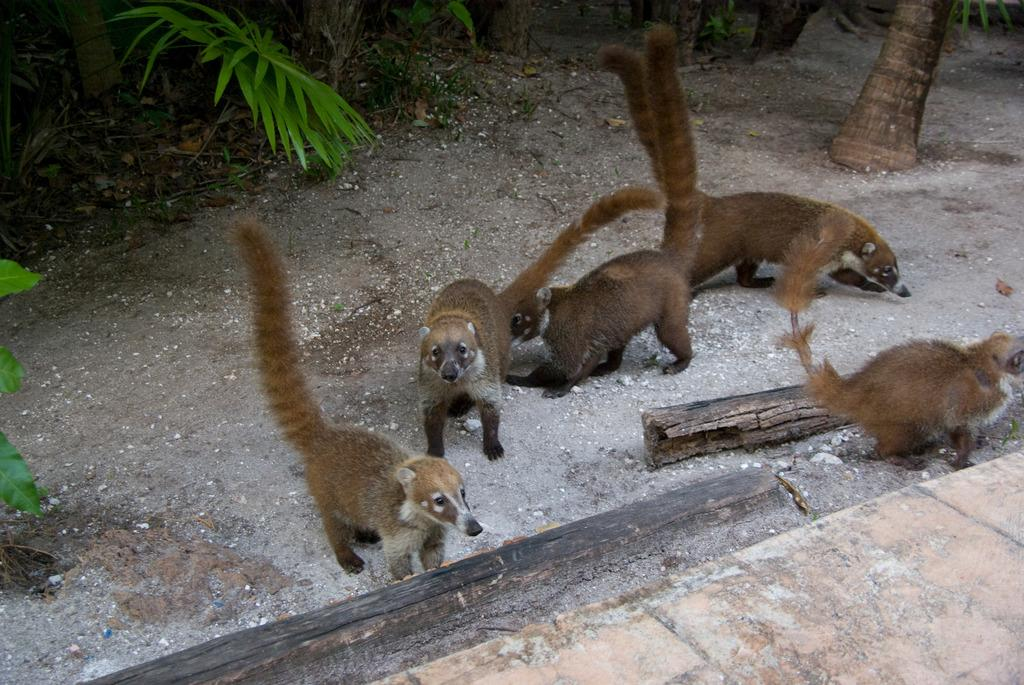How many animals are present in the image? There are five animals in the image. What is the setting of the image? The image appears to be taken in a forest. What can be seen at the bottom of the image? There is ground visible at the bottom of the image. What type of vegetation is visible in the background? There are trees in the background of the image. What type of tomatoes can be seen growing on the trees in the image? There are no tomatoes present in the image, and tomatoes do not grow on trees. 